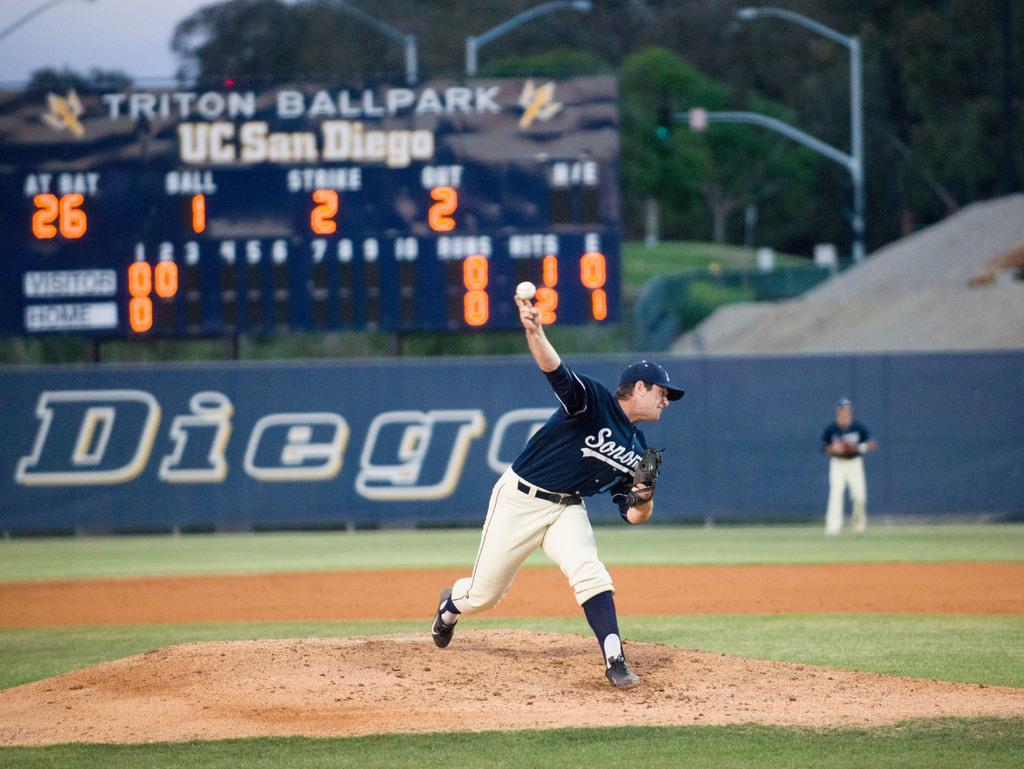<image>
Offer a succinct explanation of the picture presented. A baseball game going on at Triton Ballpark at UC San Diego. 